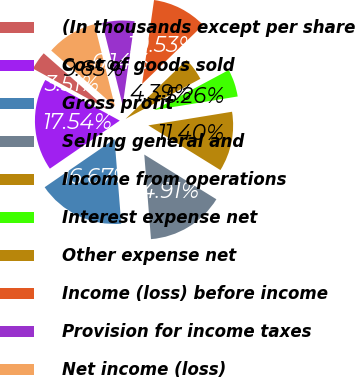Convert chart. <chart><loc_0><loc_0><loc_500><loc_500><pie_chart><fcel>(In thousands except per share<fcel>Cost of goods sold<fcel>Gross profit<fcel>Selling general and<fcel>Income from operations<fcel>Interest expense net<fcel>Other expense net<fcel>Income (loss) before income<fcel>Provision for income taxes<fcel>Net income (loss)<nl><fcel>3.51%<fcel>17.54%<fcel>16.67%<fcel>14.91%<fcel>11.4%<fcel>5.26%<fcel>4.39%<fcel>10.53%<fcel>6.14%<fcel>9.65%<nl></chart> 